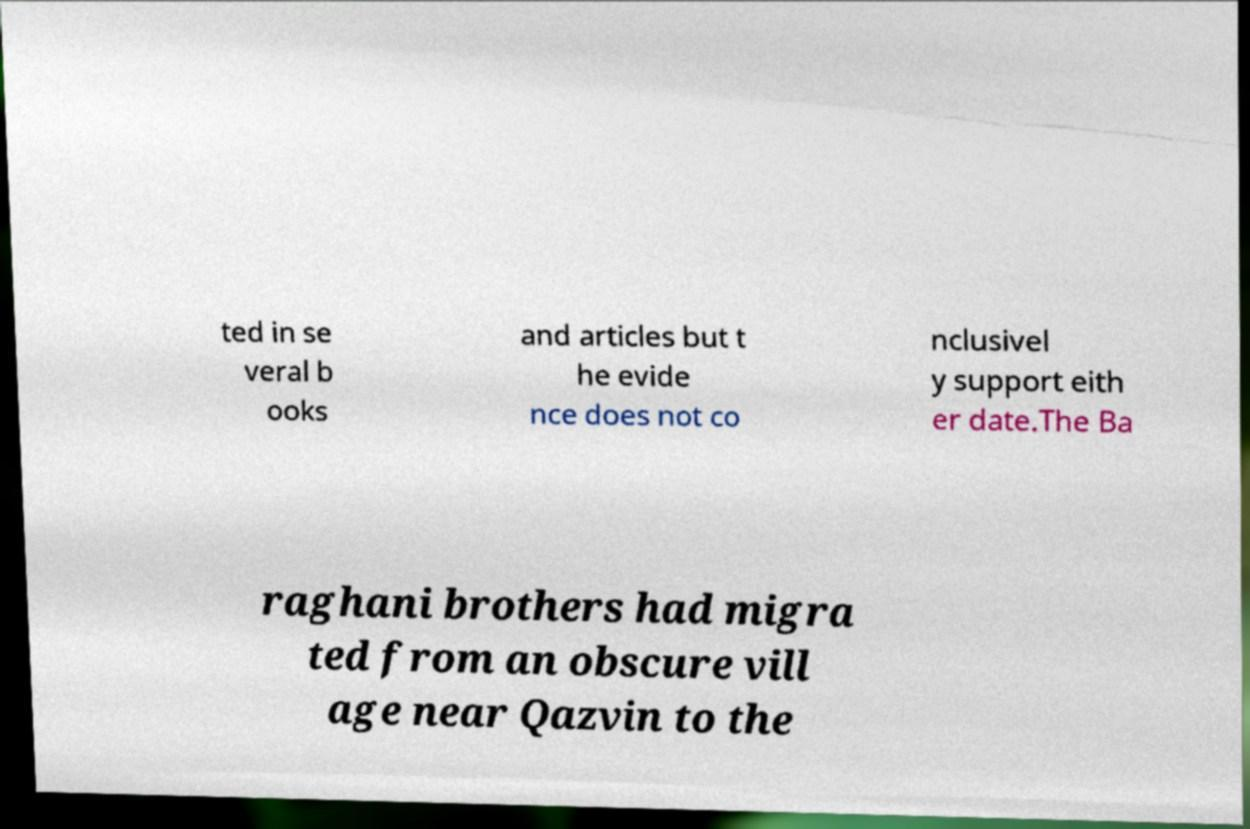I need the written content from this picture converted into text. Can you do that? ted in se veral b ooks and articles but t he evide nce does not co nclusivel y support eith er date.The Ba raghani brothers had migra ted from an obscure vill age near Qazvin to the 